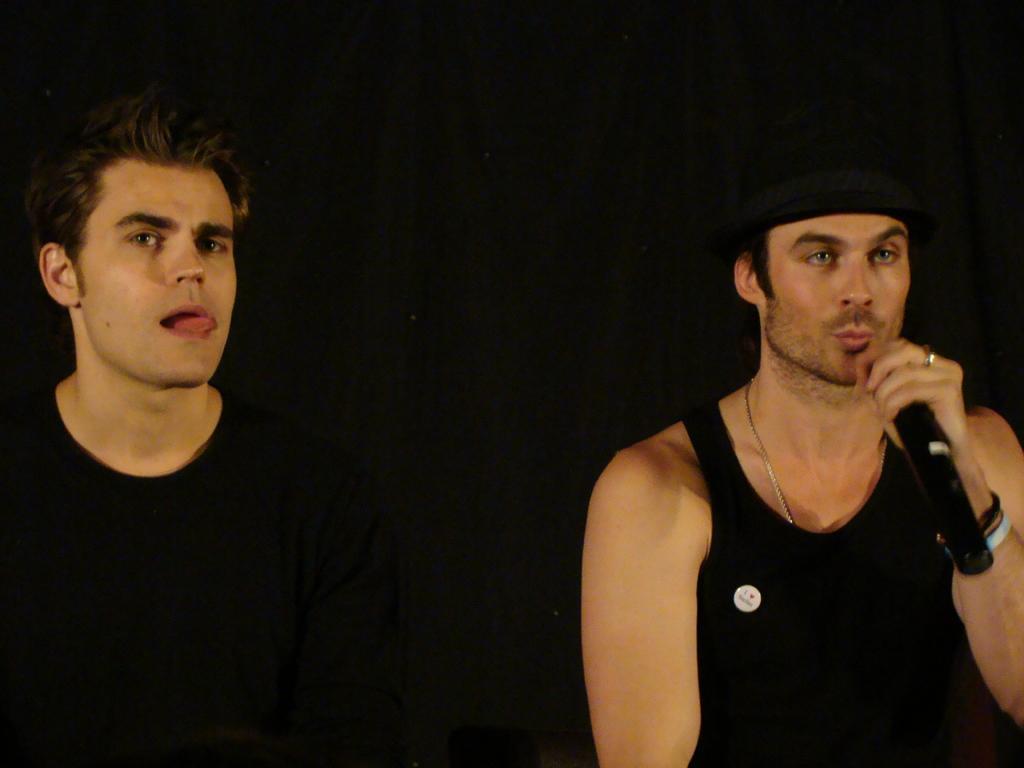Could you give a brief overview of what you see in this image? Background is very dark. We can see a man holding a mike in his hand and singing. At the left side of the picture we can see one man , he kept his tongue out of the mouth. 